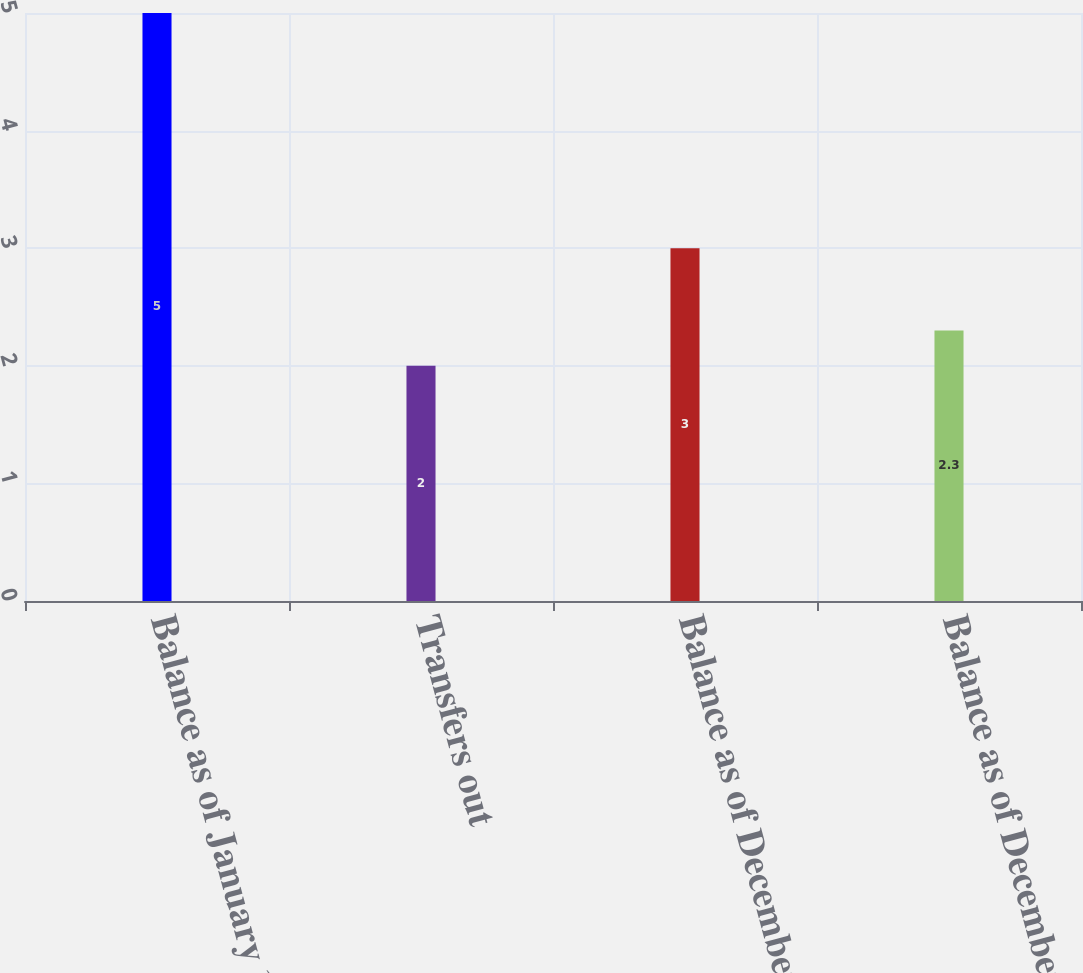<chart> <loc_0><loc_0><loc_500><loc_500><bar_chart><fcel>Balance as of January 1 2014<fcel>Transfers out<fcel>Balance as of December 31 2014<fcel>Balance as of December 31 2015<nl><fcel>5<fcel>2<fcel>3<fcel>2.3<nl></chart> 